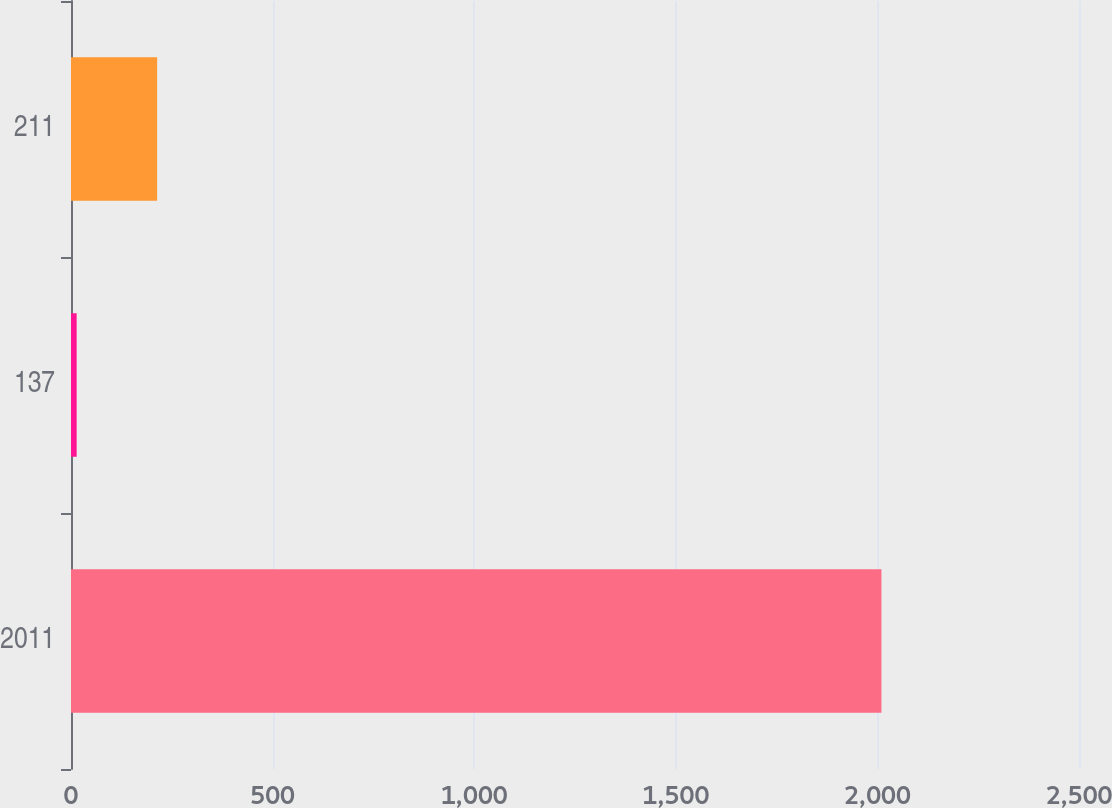<chart> <loc_0><loc_0><loc_500><loc_500><bar_chart><fcel>2011<fcel>137<fcel>211<nl><fcel>2010<fcel>14<fcel>213.6<nl></chart> 